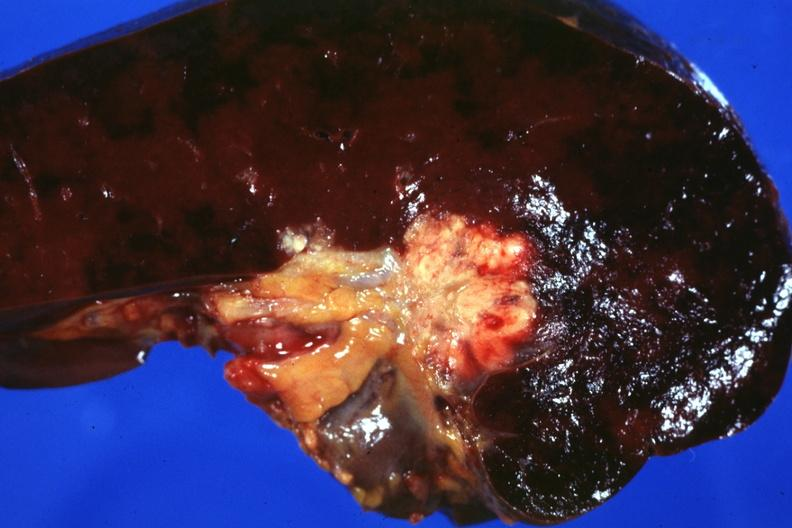how many wonder does this photo make whether node metastases spread into the spleen in this case?
Answer the question using a single word or phrase. One 